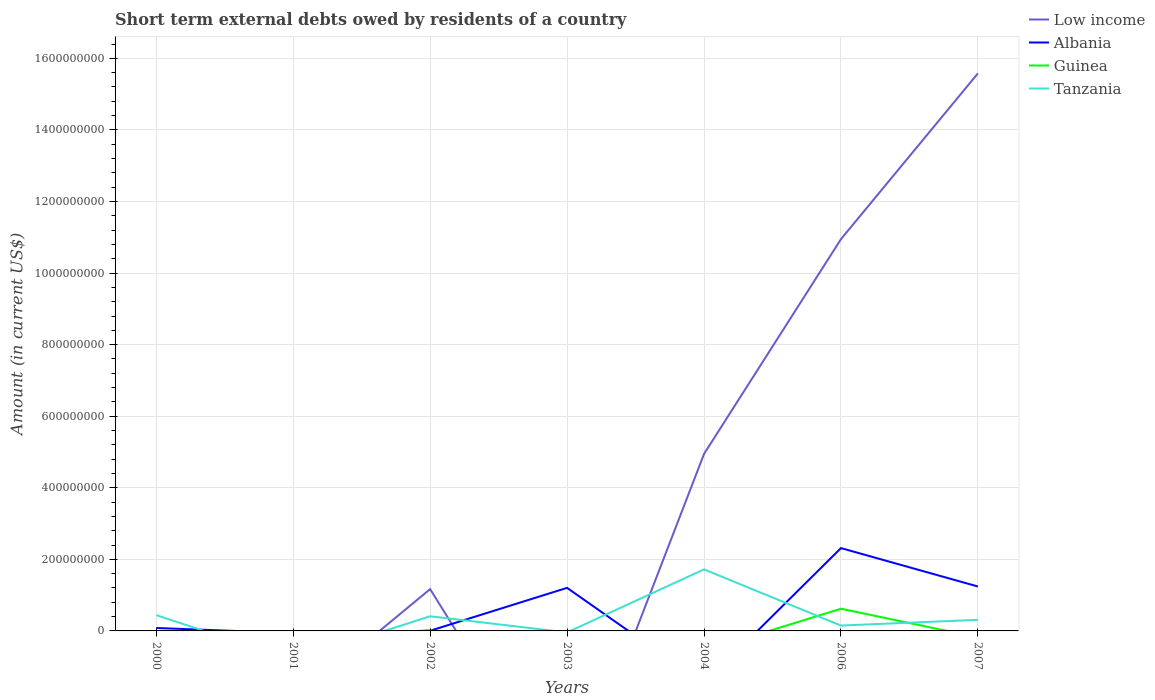How many different coloured lines are there?
Offer a very short reply. 4. Does the line corresponding to Low income intersect with the line corresponding to Albania?
Your response must be concise. Yes. Is the number of lines equal to the number of legend labels?
Your response must be concise. No. What is the total amount of short-term external debts owed by residents in Tanzania in the graph?
Give a very brief answer. 1.31e+07. What is the difference between the highest and the second highest amount of short-term external debts owed by residents in Tanzania?
Offer a very short reply. 1.72e+08. What is the difference between the highest and the lowest amount of short-term external debts owed by residents in Low income?
Provide a succinct answer. 3. What is the difference between two consecutive major ticks on the Y-axis?
Your answer should be very brief. 2.00e+08. Are the values on the major ticks of Y-axis written in scientific E-notation?
Provide a short and direct response. No. Does the graph contain any zero values?
Provide a succinct answer. Yes. Does the graph contain grids?
Make the answer very short. Yes. How many legend labels are there?
Offer a terse response. 4. What is the title of the graph?
Provide a short and direct response. Short term external debts owed by residents of a country. What is the label or title of the X-axis?
Your response must be concise. Years. What is the Amount (in current US$) in Low income in 2000?
Provide a succinct answer. 0. What is the Amount (in current US$) in Albania in 2000?
Your answer should be very brief. 8.19e+06. What is the Amount (in current US$) in Tanzania in 2000?
Your answer should be very brief. 4.41e+07. What is the Amount (in current US$) in Albania in 2001?
Provide a succinct answer. 0. What is the Amount (in current US$) in Low income in 2002?
Your response must be concise. 1.17e+08. What is the Amount (in current US$) of Albania in 2002?
Provide a short and direct response. 5.30e+05. What is the Amount (in current US$) in Guinea in 2002?
Give a very brief answer. 2.47e+06. What is the Amount (in current US$) of Tanzania in 2002?
Offer a very short reply. 4.10e+07. What is the Amount (in current US$) in Low income in 2003?
Provide a succinct answer. 0. What is the Amount (in current US$) of Albania in 2003?
Offer a terse response. 1.20e+08. What is the Amount (in current US$) in Low income in 2004?
Ensure brevity in your answer.  4.95e+08. What is the Amount (in current US$) in Albania in 2004?
Offer a very short reply. 0. What is the Amount (in current US$) of Guinea in 2004?
Make the answer very short. 0. What is the Amount (in current US$) in Tanzania in 2004?
Your answer should be very brief. 1.72e+08. What is the Amount (in current US$) in Low income in 2006?
Give a very brief answer. 1.09e+09. What is the Amount (in current US$) in Albania in 2006?
Provide a short and direct response. 2.31e+08. What is the Amount (in current US$) in Guinea in 2006?
Offer a very short reply. 6.20e+07. What is the Amount (in current US$) in Tanzania in 2006?
Your answer should be very brief. 1.50e+07. What is the Amount (in current US$) in Low income in 2007?
Your response must be concise. 1.56e+09. What is the Amount (in current US$) in Albania in 2007?
Give a very brief answer. 1.24e+08. What is the Amount (in current US$) in Tanzania in 2007?
Your response must be concise. 3.10e+07. Across all years, what is the maximum Amount (in current US$) of Low income?
Your answer should be very brief. 1.56e+09. Across all years, what is the maximum Amount (in current US$) in Albania?
Keep it short and to the point. 2.31e+08. Across all years, what is the maximum Amount (in current US$) of Guinea?
Offer a very short reply. 6.20e+07. Across all years, what is the maximum Amount (in current US$) of Tanzania?
Provide a succinct answer. 1.72e+08. Across all years, what is the minimum Amount (in current US$) in Albania?
Give a very brief answer. 0. Across all years, what is the minimum Amount (in current US$) of Guinea?
Offer a very short reply. 0. Across all years, what is the minimum Amount (in current US$) in Tanzania?
Your answer should be very brief. 0. What is the total Amount (in current US$) in Low income in the graph?
Provide a succinct answer. 3.26e+09. What is the total Amount (in current US$) in Albania in the graph?
Keep it short and to the point. 4.85e+08. What is the total Amount (in current US$) in Guinea in the graph?
Give a very brief answer. 6.45e+07. What is the total Amount (in current US$) in Tanzania in the graph?
Give a very brief answer. 3.03e+08. What is the difference between the Amount (in current US$) in Albania in 2000 and that in 2002?
Provide a succinct answer. 7.66e+06. What is the difference between the Amount (in current US$) in Tanzania in 2000 and that in 2002?
Provide a short and direct response. 3.13e+06. What is the difference between the Amount (in current US$) in Albania in 2000 and that in 2003?
Your response must be concise. -1.12e+08. What is the difference between the Amount (in current US$) of Tanzania in 2000 and that in 2004?
Keep it short and to the point. -1.28e+08. What is the difference between the Amount (in current US$) of Albania in 2000 and that in 2006?
Your answer should be very brief. -2.23e+08. What is the difference between the Amount (in current US$) in Tanzania in 2000 and that in 2006?
Your answer should be compact. 2.91e+07. What is the difference between the Amount (in current US$) of Albania in 2000 and that in 2007?
Offer a terse response. -1.16e+08. What is the difference between the Amount (in current US$) in Tanzania in 2000 and that in 2007?
Offer a terse response. 1.31e+07. What is the difference between the Amount (in current US$) in Albania in 2002 and that in 2003?
Your response must be concise. -1.20e+08. What is the difference between the Amount (in current US$) of Low income in 2002 and that in 2004?
Give a very brief answer. -3.78e+08. What is the difference between the Amount (in current US$) in Tanzania in 2002 and that in 2004?
Provide a short and direct response. -1.31e+08. What is the difference between the Amount (in current US$) in Low income in 2002 and that in 2006?
Your response must be concise. -9.78e+08. What is the difference between the Amount (in current US$) in Albania in 2002 and that in 2006?
Offer a terse response. -2.31e+08. What is the difference between the Amount (in current US$) of Guinea in 2002 and that in 2006?
Give a very brief answer. -5.95e+07. What is the difference between the Amount (in current US$) of Tanzania in 2002 and that in 2006?
Offer a very short reply. 2.60e+07. What is the difference between the Amount (in current US$) of Low income in 2002 and that in 2007?
Keep it short and to the point. -1.44e+09. What is the difference between the Amount (in current US$) in Albania in 2002 and that in 2007?
Give a very brief answer. -1.24e+08. What is the difference between the Amount (in current US$) of Tanzania in 2002 and that in 2007?
Keep it short and to the point. 9.95e+06. What is the difference between the Amount (in current US$) in Albania in 2003 and that in 2006?
Offer a very short reply. -1.11e+08. What is the difference between the Amount (in current US$) of Albania in 2003 and that in 2007?
Provide a short and direct response. -3.78e+06. What is the difference between the Amount (in current US$) in Low income in 2004 and that in 2006?
Provide a short and direct response. -6.00e+08. What is the difference between the Amount (in current US$) of Tanzania in 2004 and that in 2006?
Provide a short and direct response. 1.57e+08. What is the difference between the Amount (in current US$) of Low income in 2004 and that in 2007?
Provide a short and direct response. -1.06e+09. What is the difference between the Amount (in current US$) in Tanzania in 2004 and that in 2007?
Your answer should be compact. 1.41e+08. What is the difference between the Amount (in current US$) of Low income in 2006 and that in 2007?
Ensure brevity in your answer.  -4.63e+08. What is the difference between the Amount (in current US$) in Albania in 2006 and that in 2007?
Give a very brief answer. 1.07e+08. What is the difference between the Amount (in current US$) in Tanzania in 2006 and that in 2007?
Provide a succinct answer. -1.60e+07. What is the difference between the Amount (in current US$) in Albania in 2000 and the Amount (in current US$) in Guinea in 2002?
Ensure brevity in your answer.  5.72e+06. What is the difference between the Amount (in current US$) of Albania in 2000 and the Amount (in current US$) of Tanzania in 2002?
Provide a short and direct response. -3.28e+07. What is the difference between the Amount (in current US$) of Albania in 2000 and the Amount (in current US$) of Tanzania in 2004?
Offer a very short reply. -1.64e+08. What is the difference between the Amount (in current US$) of Albania in 2000 and the Amount (in current US$) of Guinea in 2006?
Keep it short and to the point. -5.38e+07. What is the difference between the Amount (in current US$) of Albania in 2000 and the Amount (in current US$) of Tanzania in 2006?
Make the answer very short. -6.81e+06. What is the difference between the Amount (in current US$) of Albania in 2000 and the Amount (in current US$) of Tanzania in 2007?
Give a very brief answer. -2.28e+07. What is the difference between the Amount (in current US$) in Low income in 2002 and the Amount (in current US$) in Albania in 2003?
Your answer should be compact. -3.59e+06. What is the difference between the Amount (in current US$) in Low income in 2002 and the Amount (in current US$) in Tanzania in 2004?
Ensure brevity in your answer.  -5.52e+07. What is the difference between the Amount (in current US$) in Albania in 2002 and the Amount (in current US$) in Tanzania in 2004?
Provide a succinct answer. -1.71e+08. What is the difference between the Amount (in current US$) in Guinea in 2002 and the Amount (in current US$) in Tanzania in 2004?
Provide a succinct answer. -1.70e+08. What is the difference between the Amount (in current US$) in Low income in 2002 and the Amount (in current US$) in Albania in 2006?
Give a very brief answer. -1.15e+08. What is the difference between the Amount (in current US$) in Low income in 2002 and the Amount (in current US$) in Guinea in 2006?
Your response must be concise. 5.48e+07. What is the difference between the Amount (in current US$) in Low income in 2002 and the Amount (in current US$) in Tanzania in 2006?
Your response must be concise. 1.02e+08. What is the difference between the Amount (in current US$) of Albania in 2002 and the Amount (in current US$) of Guinea in 2006?
Provide a short and direct response. -6.15e+07. What is the difference between the Amount (in current US$) in Albania in 2002 and the Amount (in current US$) in Tanzania in 2006?
Your answer should be compact. -1.45e+07. What is the difference between the Amount (in current US$) of Guinea in 2002 and the Amount (in current US$) of Tanzania in 2006?
Keep it short and to the point. -1.25e+07. What is the difference between the Amount (in current US$) of Low income in 2002 and the Amount (in current US$) of Albania in 2007?
Make the answer very short. -7.36e+06. What is the difference between the Amount (in current US$) in Low income in 2002 and the Amount (in current US$) in Tanzania in 2007?
Provide a short and direct response. 8.58e+07. What is the difference between the Amount (in current US$) in Albania in 2002 and the Amount (in current US$) in Tanzania in 2007?
Offer a very short reply. -3.05e+07. What is the difference between the Amount (in current US$) in Guinea in 2002 and the Amount (in current US$) in Tanzania in 2007?
Ensure brevity in your answer.  -2.85e+07. What is the difference between the Amount (in current US$) in Albania in 2003 and the Amount (in current US$) in Tanzania in 2004?
Offer a very short reply. -5.16e+07. What is the difference between the Amount (in current US$) in Albania in 2003 and the Amount (in current US$) in Guinea in 2006?
Offer a terse response. 5.84e+07. What is the difference between the Amount (in current US$) of Albania in 2003 and the Amount (in current US$) of Tanzania in 2006?
Your answer should be very brief. 1.05e+08. What is the difference between the Amount (in current US$) of Albania in 2003 and the Amount (in current US$) of Tanzania in 2007?
Keep it short and to the point. 8.94e+07. What is the difference between the Amount (in current US$) in Low income in 2004 and the Amount (in current US$) in Albania in 2006?
Ensure brevity in your answer.  2.63e+08. What is the difference between the Amount (in current US$) of Low income in 2004 and the Amount (in current US$) of Guinea in 2006?
Your response must be concise. 4.33e+08. What is the difference between the Amount (in current US$) in Low income in 2004 and the Amount (in current US$) in Tanzania in 2006?
Your response must be concise. 4.80e+08. What is the difference between the Amount (in current US$) in Low income in 2004 and the Amount (in current US$) in Albania in 2007?
Your response must be concise. 3.70e+08. What is the difference between the Amount (in current US$) of Low income in 2004 and the Amount (in current US$) of Tanzania in 2007?
Your response must be concise. 4.64e+08. What is the difference between the Amount (in current US$) of Low income in 2006 and the Amount (in current US$) of Albania in 2007?
Make the answer very short. 9.71e+08. What is the difference between the Amount (in current US$) in Low income in 2006 and the Amount (in current US$) in Tanzania in 2007?
Offer a very short reply. 1.06e+09. What is the difference between the Amount (in current US$) of Albania in 2006 and the Amount (in current US$) of Tanzania in 2007?
Give a very brief answer. 2.00e+08. What is the difference between the Amount (in current US$) in Guinea in 2006 and the Amount (in current US$) in Tanzania in 2007?
Your answer should be very brief. 3.10e+07. What is the average Amount (in current US$) in Low income per year?
Keep it short and to the point. 4.66e+08. What is the average Amount (in current US$) of Albania per year?
Ensure brevity in your answer.  6.92e+07. What is the average Amount (in current US$) in Guinea per year?
Your response must be concise. 9.21e+06. What is the average Amount (in current US$) of Tanzania per year?
Your answer should be compact. 4.33e+07. In the year 2000, what is the difference between the Amount (in current US$) in Albania and Amount (in current US$) in Tanzania?
Provide a succinct answer. -3.59e+07. In the year 2002, what is the difference between the Amount (in current US$) in Low income and Amount (in current US$) in Albania?
Give a very brief answer. 1.16e+08. In the year 2002, what is the difference between the Amount (in current US$) of Low income and Amount (in current US$) of Guinea?
Make the answer very short. 1.14e+08. In the year 2002, what is the difference between the Amount (in current US$) in Low income and Amount (in current US$) in Tanzania?
Give a very brief answer. 7.58e+07. In the year 2002, what is the difference between the Amount (in current US$) of Albania and Amount (in current US$) of Guinea?
Your answer should be very brief. -1.94e+06. In the year 2002, what is the difference between the Amount (in current US$) of Albania and Amount (in current US$) of Tanzania?
Your answer should be very brief. -4.04e+07. In the year 2002, what is the difference between the Amount (in current US$) of Guinea and Amount (in current US$) of Tanzania?
Your answer should be very brief. -3.85e+07. In the year 2004, what is the difference between the Amount (in current US$) in Low income and Amount (in current US$) in Tanzania?
Your response must be concise. 3.23e+08. In the year 2006, what is the difference between the Amount (in current US$) of Low income and Amount (in current US$) of Albania?
Your response must be concise. 8.63e+08. In the year 2006, what is the difference between the Amount (in current US$) in Low income and Amount (in current US$) in Guinea?
Ensure brevity in your answer.  1.03e+09. In the year 2006, what is the difference between the Amount (in current US$) of Low income and Amount (in current US$) of Tanzania?
Provide a short and direct response. 1.08e+09. In the year 2006, what is the difference between the Amount (in current US$) in Albania and Amount (in current US$) in Guinea?
Your response must be concise. 1.69e+08. In the year 2006, what is the difference between the Amount (in current US$) in Albania and Amount (in current US$) in Tanzania?
Make the answer very short. 2.16e+08. In the year 2006, what is the difference between the Amount (in current US$) in Guinea and Amount (in current US$) in Tanzania?
Offer a terse response. 4.70e+07. In the year 2007, what is the difference between the Amount (in current US$) of Low income and Amount (in current US$) of Albania?
Make the answer very short. 1.43e+09. In the year 2007, what is the difference between the Amount (in current US$) of Low income and Amount (in current US$) of Tanzania?
Make the answer very short. 1.53e+09. In the year 2007, what is the difference between the Amount (in current US$) of Albania and Amount (in current US$) of Tanzania?
Your response must be concise. 9.31e+07. What is the ratio of the Amount (in current US$) of Albania in 2000 to that in 2002?
Offer a very short reply. 15.45. What is the ratio of the Amount (in current US$) of Tanzania in 2000 to that in 2002?
Your answer should be very brief. 1.08. What is the ratio of the Amount (in current US$) in Albania in 2000 to that in 2003?
Provide a short and direct response. 0.07. What is the ratio of the Amount (in current US$) of Tanzania in 2000 to that in 2004?
Your answer should be very brief. 0.26. What is the ratio of the Amount (in current US$) in Albania in 2000 to that in 2006?
Your answer should be compact. 0.04. What is the ratio of the Amount (in current US$) of Tanzania in 2000 to that in 2006?
Your answer should be very brief. 2.94. What is the ratio of the Amount (in current US$) of Albania in 2000 to that in 2007?
Make the answer very short. 0.07. What is the ratio of the Amount (in current US$) in Tanzania in 2000 to that in 2007?
Ensure brevity in your answer.  1.42. What is the ratio of the Amount (in current US$) in Albania in 2002 to that in 2003?
Give a very brief answer. 0. What is the ratio of the Amount (in current US$) of Low income in 2002 to that in 2004?
Keep it short and to the point. 0.24. What is the ratio of the Amount (in current US$) of Tanzania in 2002 to that in 2004?
Provide a succinct answer. 0.24. What is the ratio of the Amount (in current US$) in Low income in 2002 to that in 2006?
Your answer should be compact. 0.11. What is the ratio of the Amount (in current US$) in Albania in 2002 to that in 2006?
Keep it short and to the point. 0. What is the ratio of the Amount (in current US$) of Guinea in 2002 to that in 2006?
Provide a short and direct response. 0.04. What is the ratio of the Amount (in current US$) of Tanzania in 2002 to that in 2006?
Your answer should be very brief. 2.73. What is the ratio of the Amount (in current US$) of Low income in 2002 to that in 2007?
Give a very brief answer. 0.07. What is the ratio of the Amount (in current US$) in Albania in 2002 to that in 2007?
Give a very brief answer. 0. What is the ratio of the Amount (in current US$) of Tanzania in 2002 to that in 2007?
Provide a succinct answer. 1.32. What is the ratio of the Amount (in current US$) of Albania in 2003 to that in 2006?
Keep it short and to the point. 0.52. What is the ratio of the Amount (in current US$) in Albania in 2003 to that in 2007?
Your response must be concise. 0.97. What is the ratio of the Amount (in current US$) of Low income in 2004 to that in 2006?
Give a very brief answer. 0.45. What is the ratio of the Amount (in current US$) in Tanzania in 2004 to that in 2006?
Keep it short and to the point. 11.47. What is the ratio of the Amount (in current US$) of Low income in 2004 to that in 2007?
Offer a very short reply. 0.32. What is the ratio of the Amount (in current US$) of Tanzania in 2004 to that in 2007?
Ensure brevity in your answer.  5.55. What is the ratio of the Amount (in current US$) of Low income in 2006 to that in 2007?
Give a very brief answer. 0.7. What is the ratio of the Amount (in current US$) of Albania in 2006 to that in 2007?
Make the answer very short. 1.86. What is the ratio of the Amount (in current US$) in Tanzania in 2006 to that in 2007?
Provide a short and direct response. 0.48. What is the difference between the highest and the second highest Amount (in current US$) of Low income?
Your response must be concise. 4.63e+08. What is the difference between the highest and the second highest Amount (in current US$) of Albania?
Your response must be concise. 1.07e+08. What is the difference between the highest and the second highest Amount (in current US$) in Tanzania?
Keep it short and to the point. 1.28e+08. What is the difference between the highest and the lowest Amount (in current US$) of Low income?
Give a very brief answer. 1.56e+09. What is the difference between the highest and the lowest Amount (in current US$) in Albania?
Your answer should be compact. 2.31e+08. What is the difference between the highest and the lowest Amount (in current US$) of Guinea?
Provide a succinct answer. 6.20e+07. What is the difference between the highest and the lowest Amount (in current US$) of Tanzania?
Make the answer very short. 1.72e+08. 